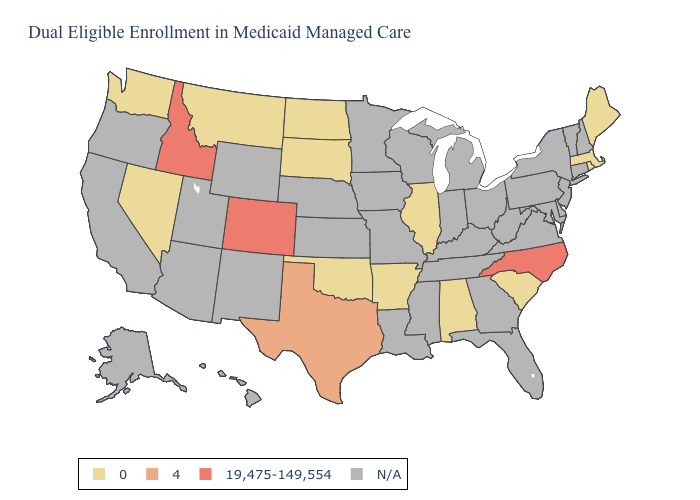Does Arkansas have the lowest value in the South?
Concise answer only. Yes. What is the value of Louisiana?
Concise answer only. N/A. Name the states that have a value in the range N/A?
Give a very brief answer. Alaska, Arizona, California, Connecticut, Delaware, Florida, Georgia, Hawaii, Indiana, Iowa, Kansas, Kentucky, Louisiana, Maryland, Michigan, Minnesota, Mississippi, Missouri, Nebraska, New Hampshire, New Jersey, New Mexico, New York, Ohio, Oregon, Pennsylvania, Tennessee, Utah, Vermont, Virginia, West Virginia, Wisconsin, Wyoming. What is the lowest value in the USA?
Write a very short answer. 0. Name the states that have a value in the range 19,475-149,554?
Concise answer only. Colorado, Idaho, North Carolina. What is the value of Iowa?
Keep it brief. N/A. What is the highest value in the MidWest ?
Answer briefly. 0. How many symbols are there in the legend?
Short answer required. 4. Which states have the highest value in the USA?
Be succinct. Colorado, Idaho, North Carolina. Among the states that border Kentucky , which have the lowest value?
Write a very short answer. Illinois. 